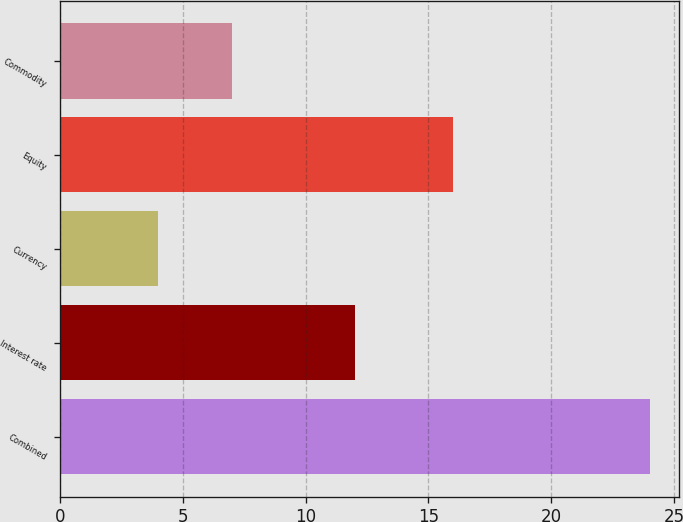Convert chart. <chart><loc_0><loc_0><loc_500><loc_500><bar_chart><fcel>Combined<fcel>Interest rate<fcel>Currency<fcel>Equity<fcel>Commodity<nl><fcel>24<fcel>12<fcel>4<fcel>16<fcel>7<nl></chart> 